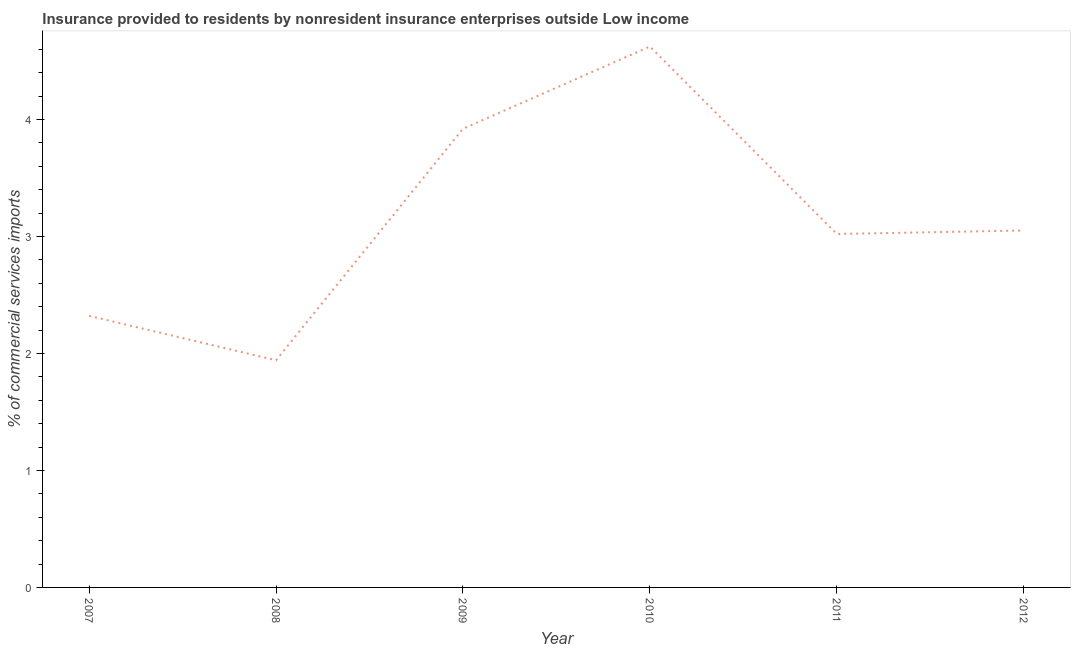What is the insurance provided by non-residents in 2010?
Provide a succinct answer. 4.62. Across all years, what is the maximum insurance provided by non-residents?
Keep it short and to the point. 4.62. Across all years, what is the minimum insurance provided by non-residents?
Your response must be concise. 1.94. In which year was the insurance provided by non-residents minimum?
Make the answer very short. 2008. What is the sum of the insurance provided by non-residents?
Offer a terse response. 18.88. What is the difference between the insurance provided by non-residents in 2008 and 2012?
Provide a succinct answer. -1.11. What is the average insurance provided by non-residents per year?
Your answer should be compact. 3.15. What is the median insurance provided by non-residents?
Keep it short and to the point. 3.04. In how many years, is the insurance provided by non-residents greater than 3.6 %?
Your answer should be very brief. 2. What is the ratio of the insurance provided by non-residents in 2007 to that in 2009?
Provide a succinct answer. 0.59. Is the insurance provided by non-residents in 2009 less than that in 2010?
Provide a short and direct response. Yes. What is the difference between the highest and the second highest insurance provided by non-residents?
Offer a terse response. 0.7. What is the difference between the highest and the lowest insurance provided by non-residents?
Provide a succinct answer. 2.68. How many years are there in the graph?
Make the answer very short. 6. What is the difference between two consecutive major ticks on the Y-axis?
Provide a short and direct response. 1. Are the values on the major ticks of Y-axis written in scientific E-notation?
Provide a succinct answer. No. Does the graph contain any zero values?
Your answer should be very brief. No. What is the title of the graph?
Make the answer very short. Insurance provided to residents by nonresident insurance enterprises outside Low income. What is the label or title of the X-axis?
Give a very brief answer. Year. What is the label or title of the Y-axis?
Ensure brevity in your answer.  % of commercial services imports. What is the % of commercial services imports in 2007?
Offer a very short reply. 2.32. What is the % of commercial services imports of 2008?
Keep it short and to the point. 1.94. What is the % of commercial services imports in 2009?
Your response must be concise. 3.92. What is the % of commercial services imports of 2010?
Your answer should be compact. 4.62. What is the % of commercial services imports of 2011?
Provide a short and direct response. 3.02. What is the % of commercial services imports of 2012?
Ensure brevity in your answer.  3.05. What is the difference between the % of commercial services imports in 2007 and 2008?
Offer a very short reply. 0.38. What is the difference between the % of commercial services imports in 2007 and 2009?
Provide a short and direct response. -1.6. What is the difference between the % of commercial services imports in 2007 and 2010?
Ensure brevity in your answer.  -2.3. What is the difference between the % of commercial services imports in 2007 and 2011?
Offer a very short reply. -0.7. What is the difference between the % of commercial services imports in 2007 and 2012?
Give a very brief answer. -0.73. What is the difference between the % of commercial services imports in 2008 and 2009?
Your answer should be very brief. -1.98. What is the difference between the % of commercial services imports in 2008 and 2010?
Keep it short and to the point. -2.68. What is the difference between the % of commercial services imports in 2008 and 2011?
Your response must be concise. -1.08. What is the difference between the % of commercial services imports in 2008 and 2012?
Provide a short and direct response. -1.11. What is the difference between the % of commercial services imports in 2009 and 2010?
Your answer should be very brief. -0.7. What is the difference between the % of commercial services imports in 2009 and 2011?
Make the answer very short. 0.9. What is the difference between the % of commercial services imports in 2009 and 2012?
Ensure brevity in your answer.  0.87. What is the difference between the % of commercial services imports in 2010 and 2011?
Offer a terse response. 1.6. What is the difference between the % of commercial services imports in 2010 and 2012?
Provide a short and direct response. 1.57. What is the difference between the % of commercial services imports in 2011 and 2012?
Your answer should be compact. -0.03. What is the ratio of the % of commercial services imports in 2007 to that in 2008?
Give a very brief answer. 1.2. What is the ratio of the % of commercial services imports in 2007 to that in 2009?
Provide a short and direct response. 0.59. What is the ratio of the % of commercial services imports in 2007 to that in 2010?
Offer a terse response. 0.5. What is the ratio of the % of commercial services imports in 2007 to that in 2011?
Your response must be concise. 0.77. What is the ratio of the % of commercial services imports in 2007 to that in 2012?
Ensure brevity in your answer.  0.76. What is the ratio of the % of commercial services imports in 2008 to that in 2009?
Keep it short and to the point. 0.49. What is the ratio of the % of commercial services imports in 2008 to that in 2010?
Your answer should be compact. 0.42. What is the ratio of the % of commercial services imports in 2008 to that in 2011?
Offer a terse response. 0.64. What is the ratio of the % of commercial services imports in 2008 to that in 2012?
Make the answer very short. 0.64. What is the ratio of the % of commercial services imports in 2009 to that in 2010?
Make the answer very short. 0.85. What is the ratio of the % of commercial services imports in 2009 to that in 2011?
Your answer should be compact. 1.3. What is the ratio of the % of commercial services imports in 2009 to that in 2012?
Your response must be concise. 1.28. What is the ratio of the % of commercial services imports in 2010 to that in 2011?
Provide a short and direct response. 1.53. What is the ratio of the % of commercial services imports in 2010 to that in 2012?
Provide a succinct answer. 1.51. 